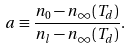<formula> <loc_0><loc_0><loc_500><loc_500>a \equiv \frac { n _ { 0 } - n _ { \infty } ( T _ { d } ) } { n _ { l } - n _ { \infty } ( T _ { d } ) } .</formula> 